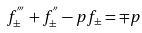Convert formula to latex. <formula><loc_0><loc_0><loc_500><loc_500>f _ { \pm } ^ { ^ { \prime \prime \prime } } + f _ { \pm } ^ { ^ { \prime \prime } } - p f _ { \pm } = \mp p</formula> 